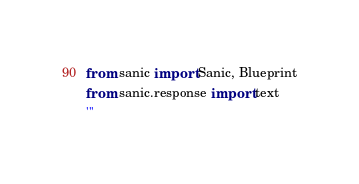Convert code to text. <code><loc_0><loc_0><loc_500><loc_500><_Python_>from sanic import Sanic, Blueprint
from sanic.response import text
'''</code> 